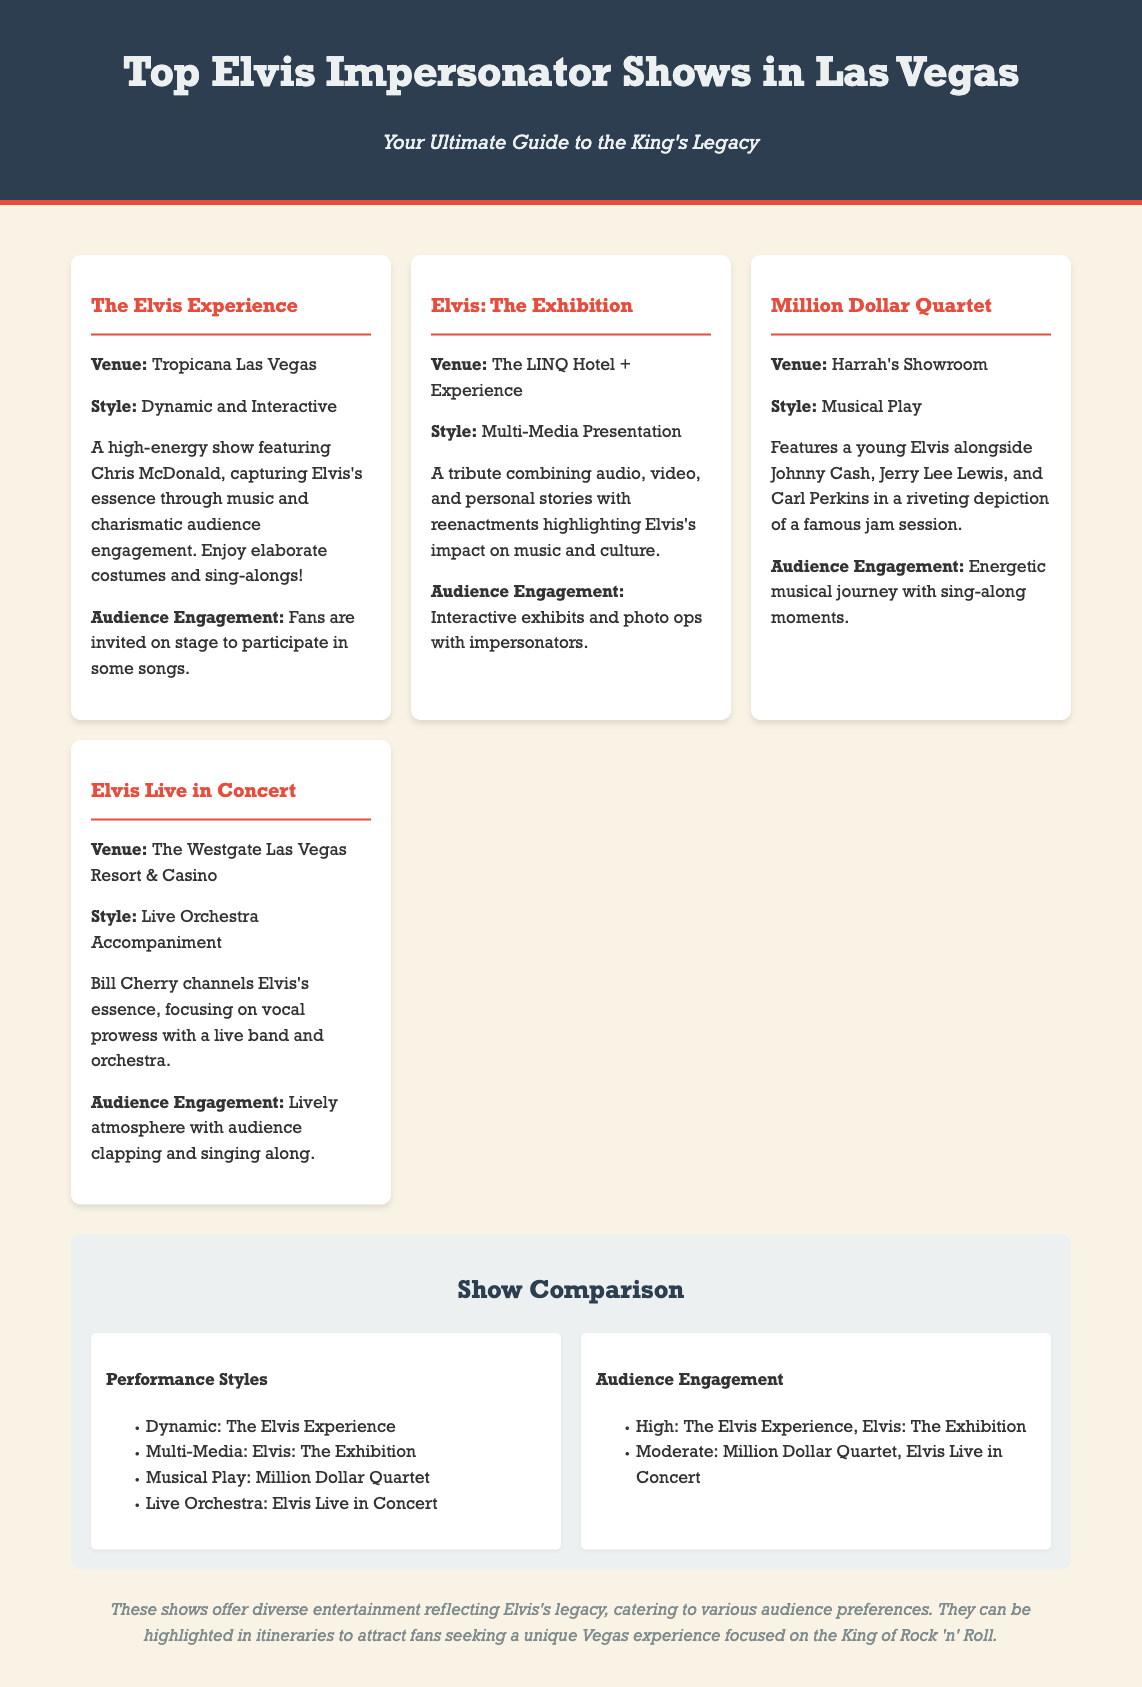What is the venue for The Elvis Experience? The venue for The Elvis Experience is mentioned in the document as Tropicana Las Vegas.
Answer: Tropicana Las Vegas What style does Elvis: The Exhibition use? The document describes Elvis: The Exhibition as a Multi-Media Presentation.
Answer: Multi-Media Presentation Which show features a young Elvis? The Million Dollar Quartet features a young Elvis alongside other iconic musicians.
Answer: Million Dollar Quartet What type of show is Elvis Live in Concert? The document categorizes Elvis Live in Concert as having Live Orchestra Accompaniment.
Answer: Live Orchestra Accompaniment Which show has interactive exhibits? The Elvis: The Exhibition includes interactive exhibits and photo ops with impersonators.
Answer: Elvis: The Exhibition What type of performance style is exhibited in Million Dollar Quartet? The Million Dollar Quartet is categorized as a Musical Play in the document.
Answer: Musical Play How many shows are listed in the document? The document lists four different Elvis impersonator shows in Las Vegas.
Answer: Four What is the overall theme of the shows presented? The shows presented reflect the King of Rock 'n' Roll's legacy, as stated in the conclusion.
Answer: Elvis's legacy 